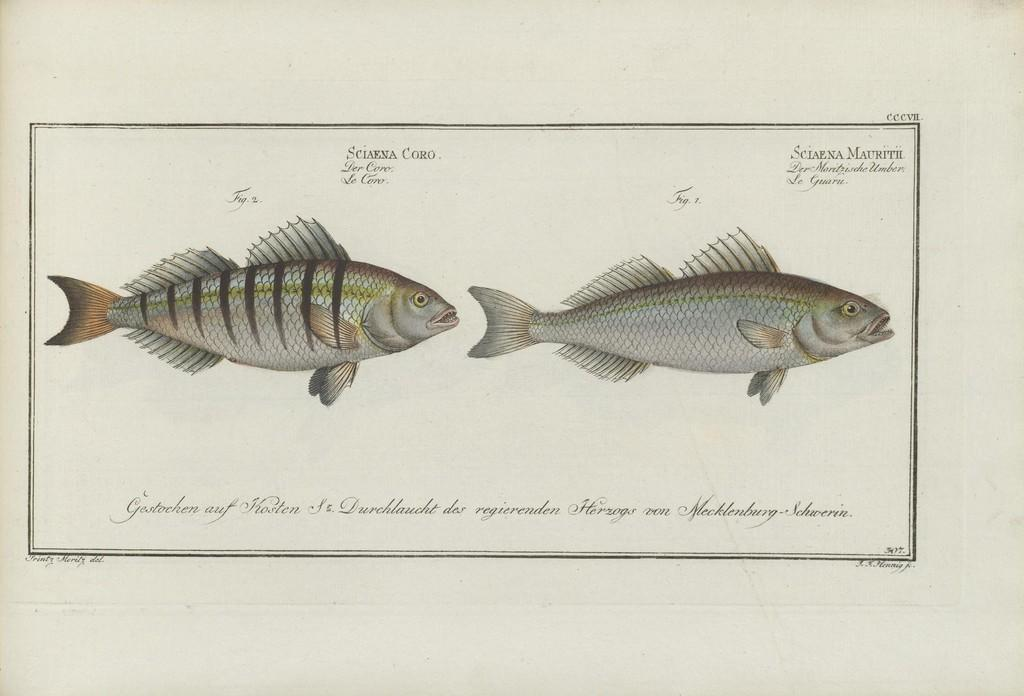What type of animals are depicted in the image? There are depictions of fish in the image. What else can be seen in the image besides the fish? There is a paper with information in the image. What time of day does the image depict the loss of the pump? The image does not depict any loss of a pump, nor does it indicate a specific time of day. 